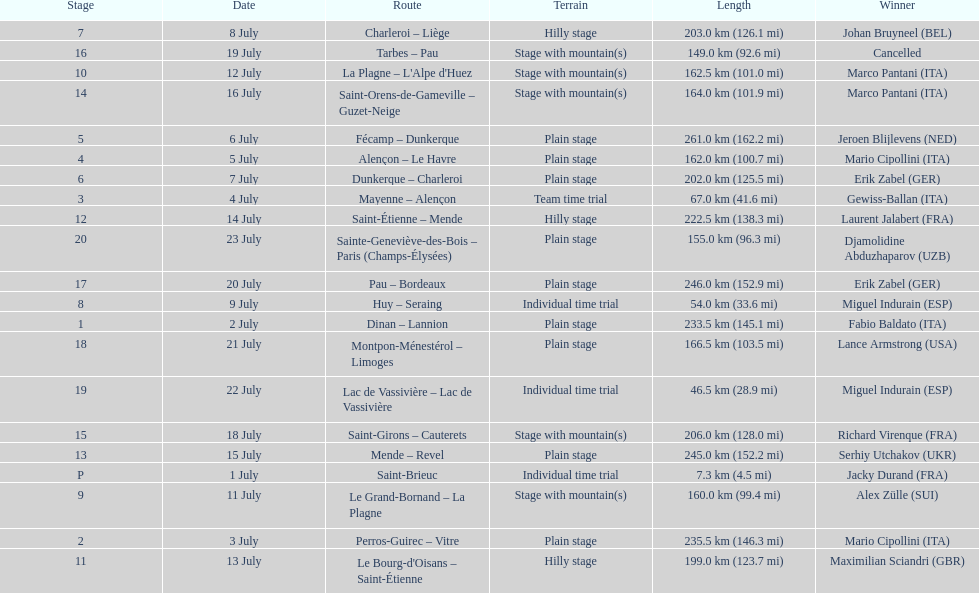Which routes were at least 100 km? Dinan - Lannion, Perros-Guirec - Vitre, Alençon - Le Havre, Fécamp - Dunkerque, Dunkerque - Charleroi, Charleroi - Liège, Le Grand-Bornand - La Plagne, La Plagne - L'Alpe d'Huez, Le Bourg-d'Oisans - Saint-Étienne, Saint-Étienne - Mende, Mende - Revel, Saint-Orens-de-Gameville - Guzet-Neige, Saint-Girons - Cauterets, Tarbes - Pau, Pau - Bordeaux, Montpon-Ménestérol - Limoges, Sainte-Geneviève-des-Bois - Paris (Champs-Élysées). 